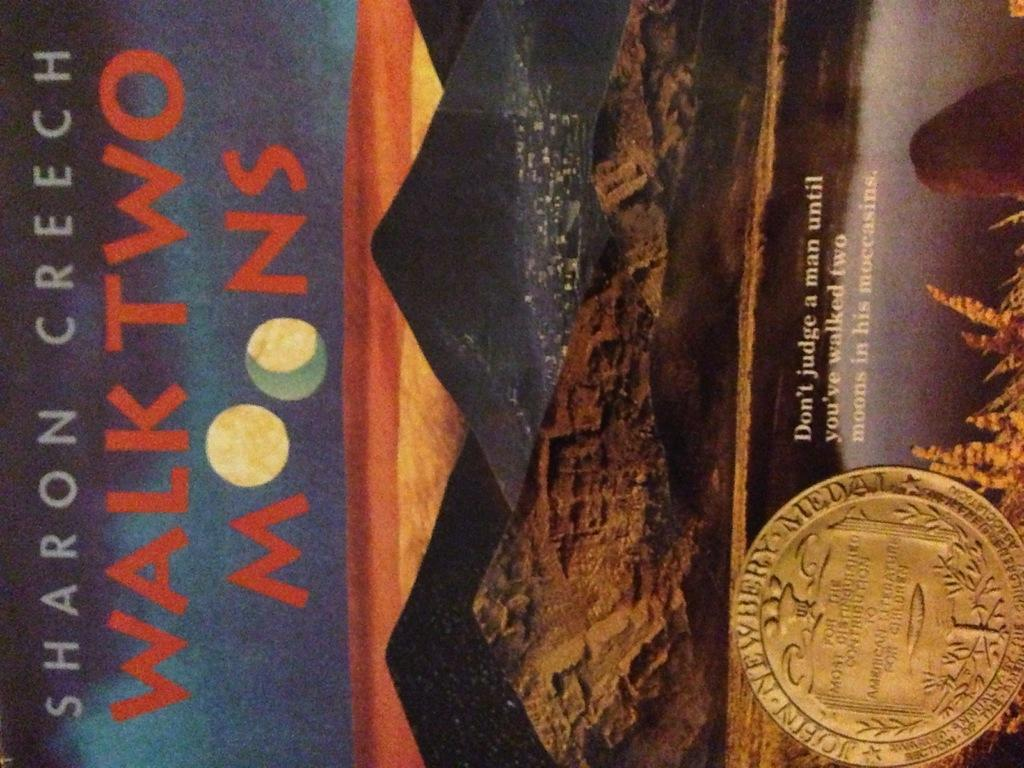<image>
Relay a brief, clear account of the picture shown. The cover of the book "Walking Two Moons" with the artwork of a city surrounded by several pyramid shaped mountains. 